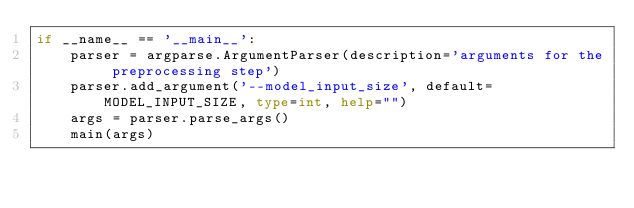Convert code to text. <code><loc_0><loc_0><loc_500><loc_500><_Python_>if __name__ == '__main__':
    parser = argparse.ArgumentParser(description='arguments for the preprocessing step')
    parser.add_argument('--model_input_size', default=MODEL_INPUT_SIZE, type=int, help="")
    args = parser.parse_args()
    main(args)
</code> 